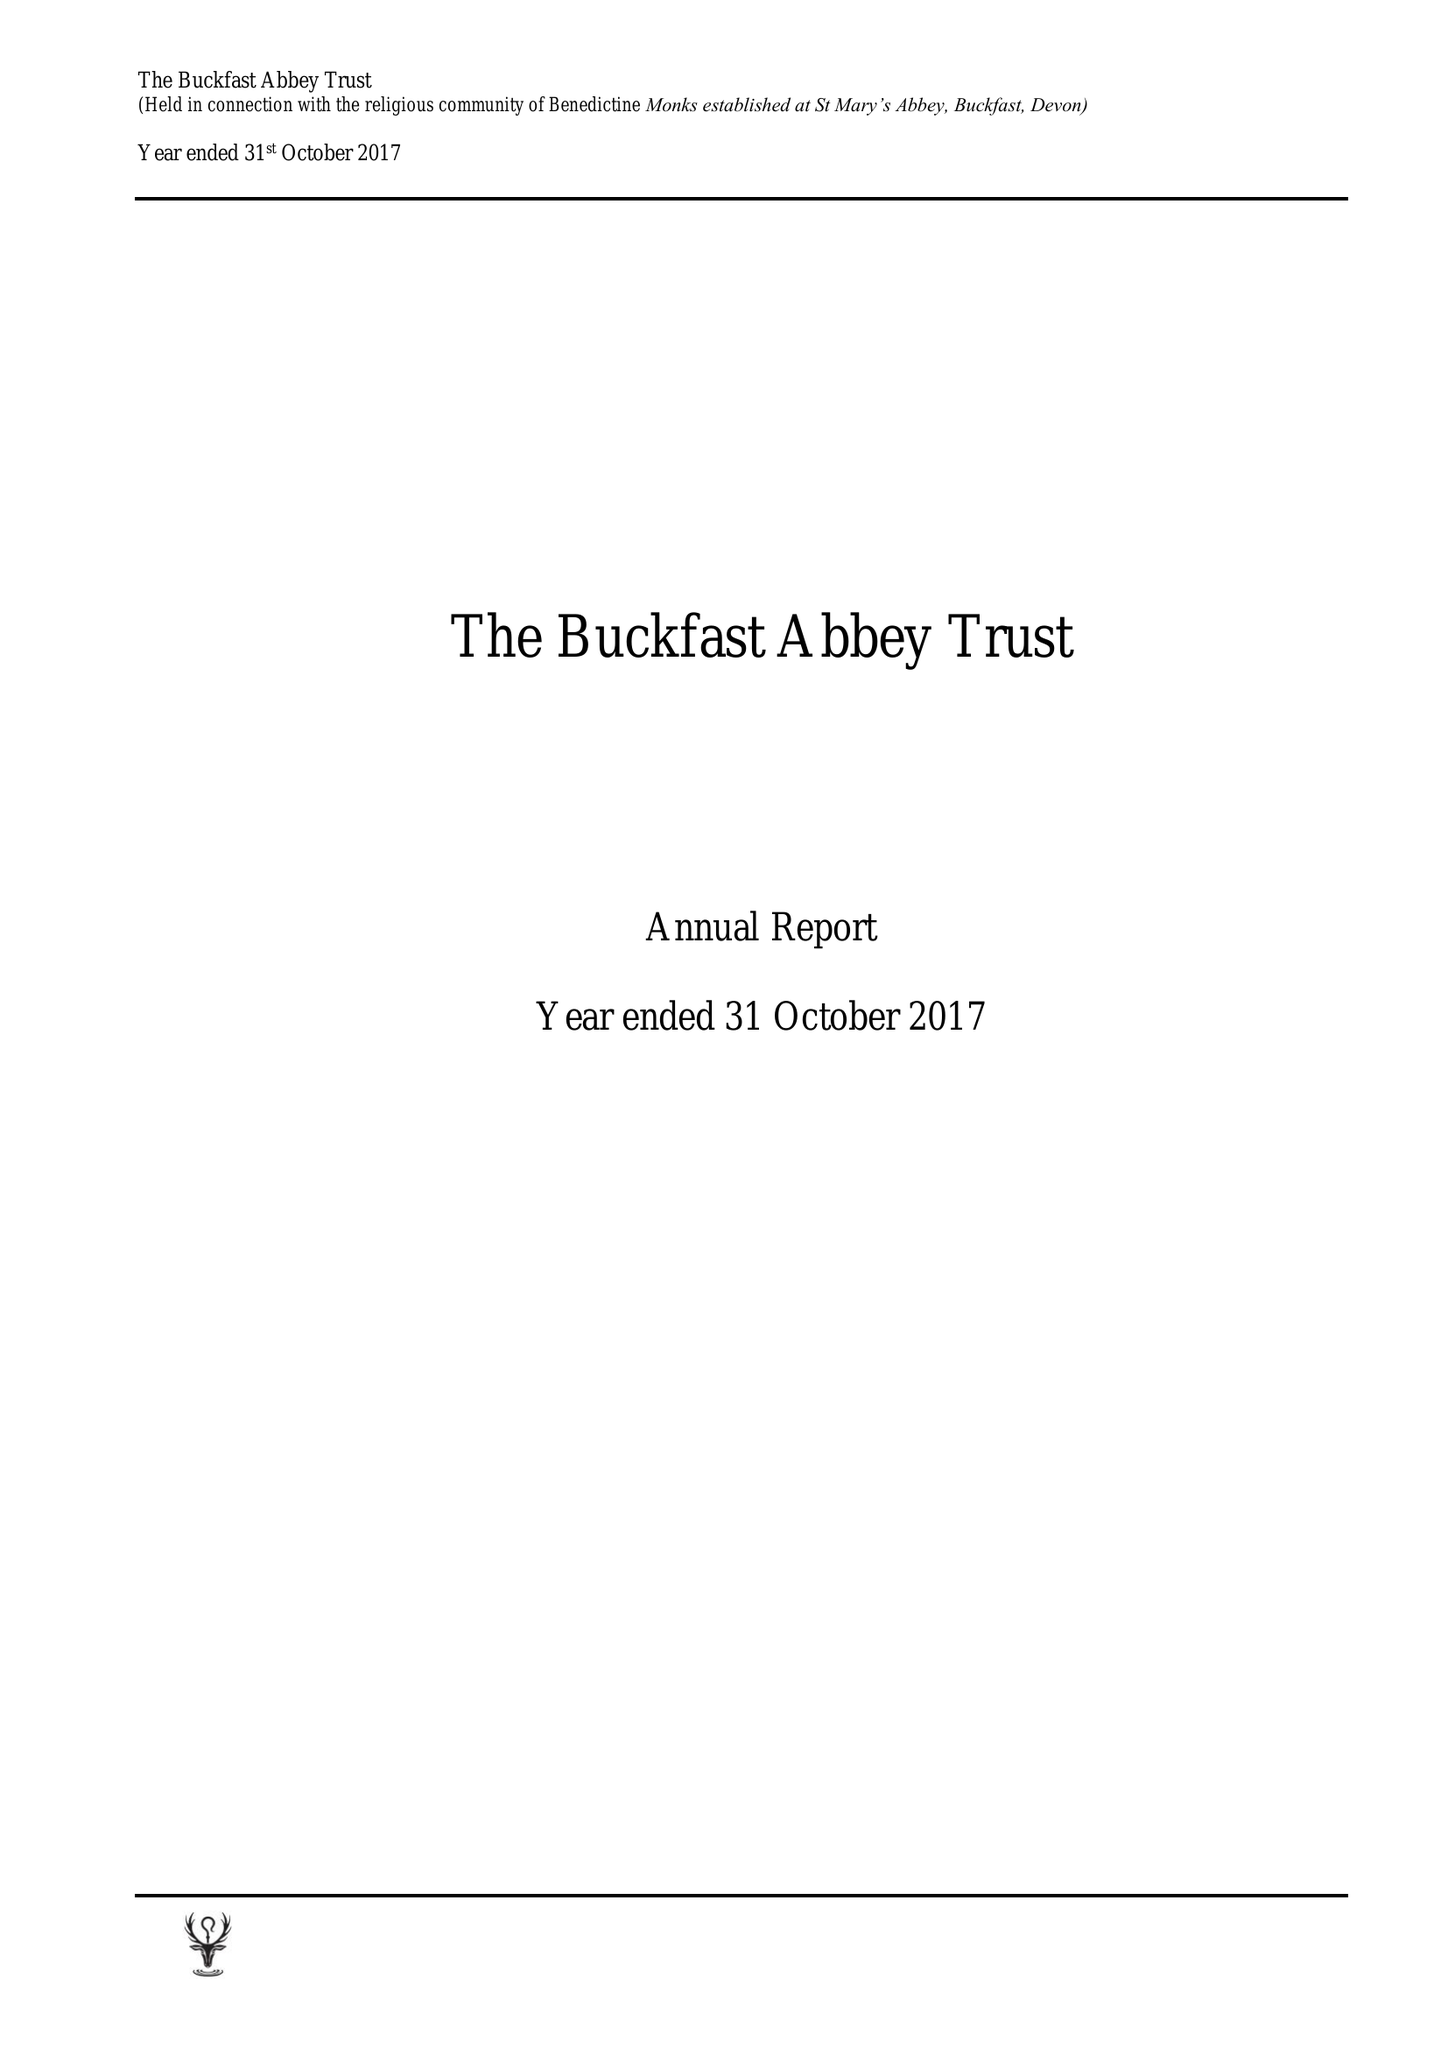What is the value for the address__street_line?
Answer the question using a single word or phrase. None 